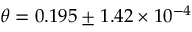Convert formula to latex. <formula><loc_0><loc_0><loc_500><loc_500>\theta = 0 . 1 9 5 \pm 1 . 4 2 \times 1 0 ^ { - 4 }</formula> 